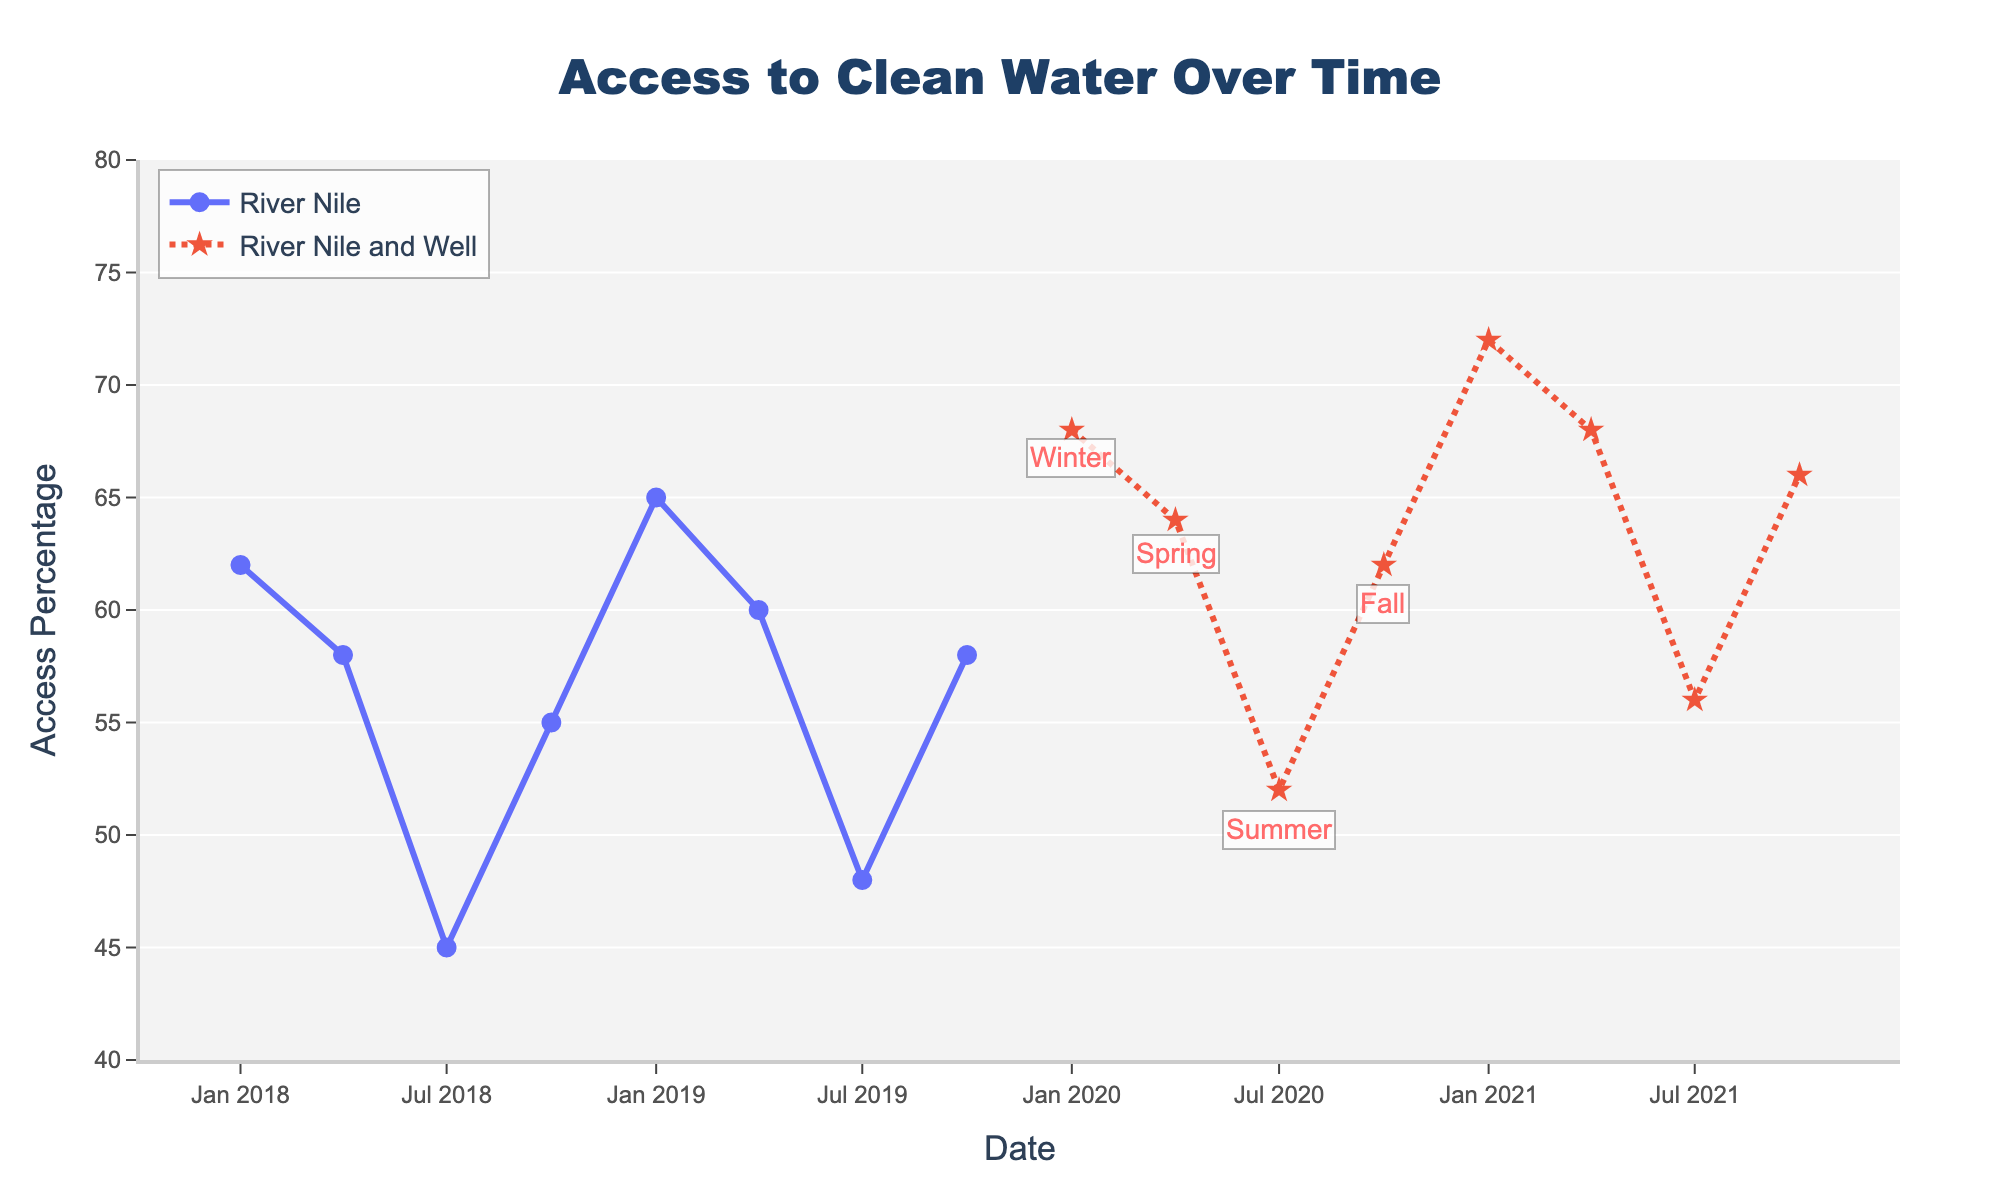Which season shows the highest access percentage in any recorded year? Based on the annotations for seasons, January represents Winter and has the highest access percentage of 72% in January 2021.
Answer: Winter How does the access percentage change from January to April in 2020? In January 2020, the access percentage is 68%, and in April 2020, it is 64%. The change is 68% - 64% = 4%.
Answer: Decreases by 4% For which time period do we see a dotted line and a star marker? The dotted line and star marker represent the period from January 2020 onward when both the River Nile and Well are used as water sources. This starts from January 2020 to October 2021.
Answer: January 2020 onward What is the difference in access percentage between Summer of 2019 and Summer of 2021? Summer is represented by July. For July 2019, the access percentage is 48%, and for July 2021, it is 56%. The difference is 56% - 48% = 8%.
Answer: 8% How does the access percentage compare between Fall 2018 and Fall 2020? Fall is represented by October. The access percentage in October 2018 is 55%, while in October 2020, it is 62%. 62% is greater than 55%.
Answer: Higher in 2020 Which year shows the highest overall access percentage for January? By comparing the access percentages for January across different years: 2018 - 62%, 2019 - 65%, 2020 - 68%, 2021 - 72%. The highest is January 2021 with 72%.
Answer: 2021 What is the average access percentage for all recorded data points in April? The access percentages for April are: 2018 - 58%, 2019 - 60%, 2020 - 64%, 2021 - 68%. The average is (58 + 60 + 64 + 68) / 4 = 62.5%.
Answer: 62.5% Which period shows the least access percentage and what was the value? The lowest access percentage is in July 2018 with a value of 45%.
Answer: July 2018, 45% 